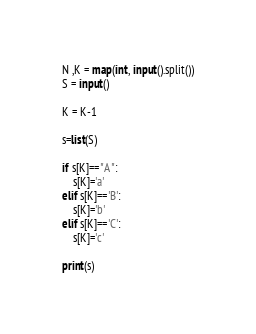Convert code to text. <code><loc_0><loc_0><loc_500><loc_500><_Python_>N ,K = map(int, input().split())
S = input()

K = K-1

s=list(S)

if s[K]=="A":
    s[K]='a'
elif s[K]=='B':
    s[K]='b'
elif s[K]=='C':
    s[K]='c'

print(s)</code> 